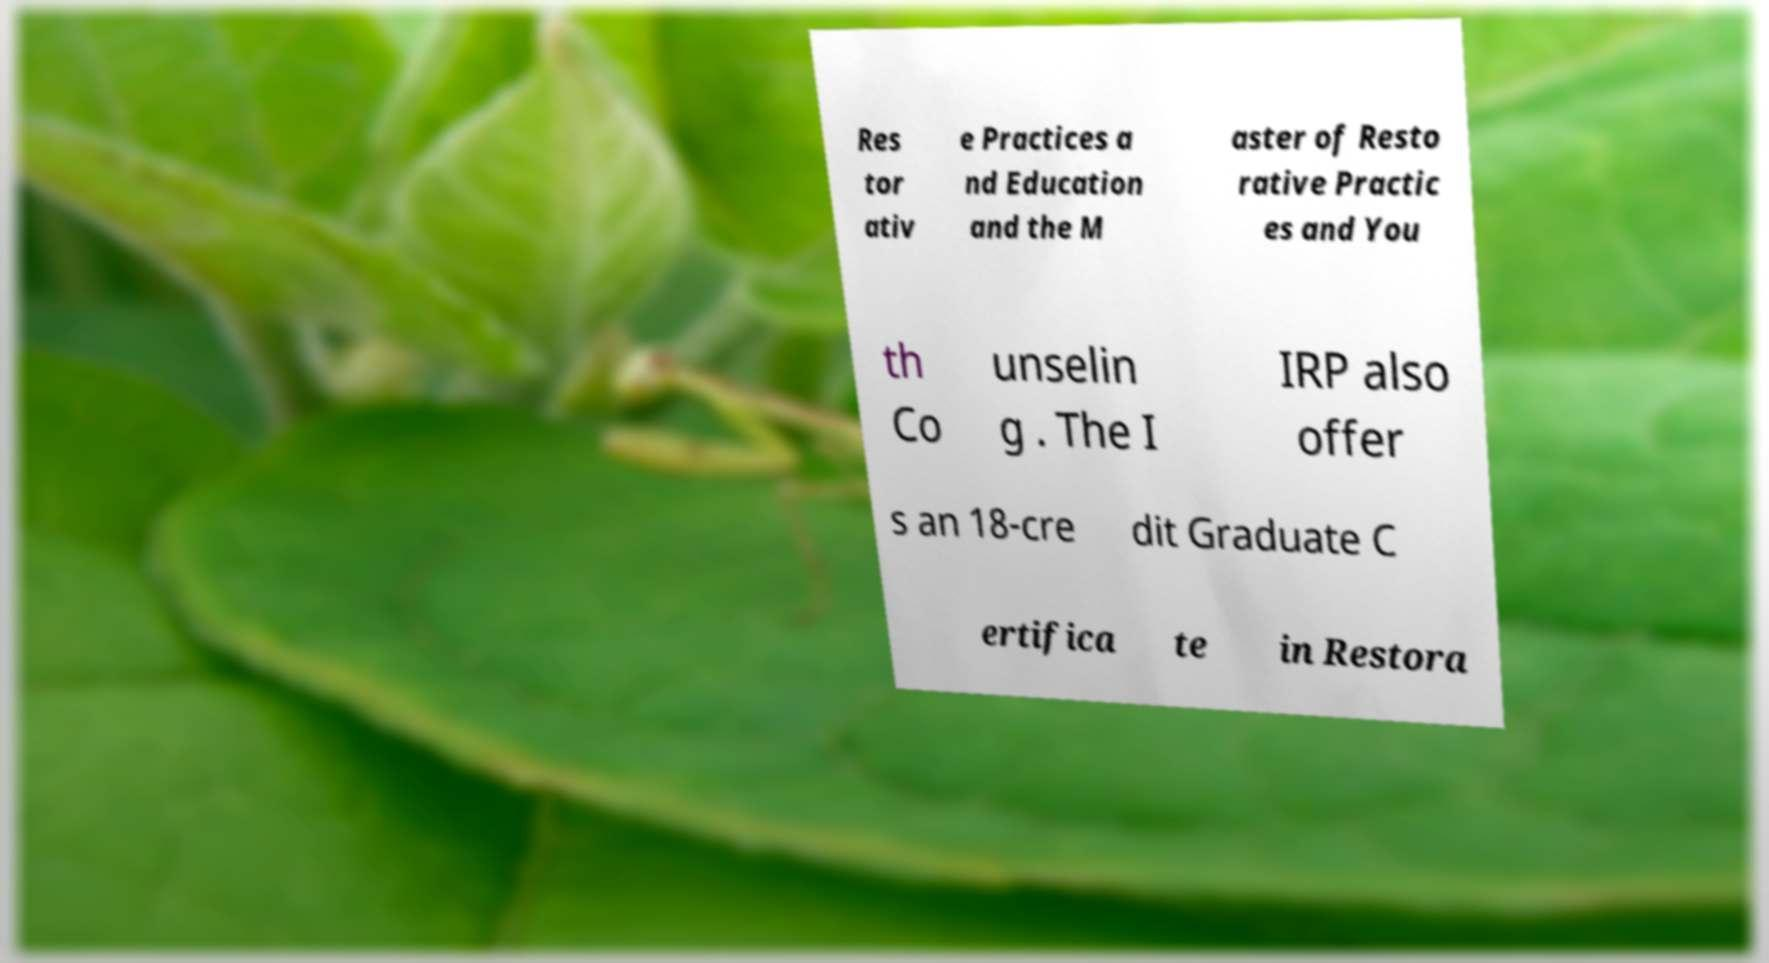Please read and relay the text visible in this image. What does it say? Res tor ativ e Practices a nd Education and the M aster of Resto rative Practic es and You th Co unselin g . The I IRP also offer s an 18-cre dit Graduate C ertifica te in Restora 